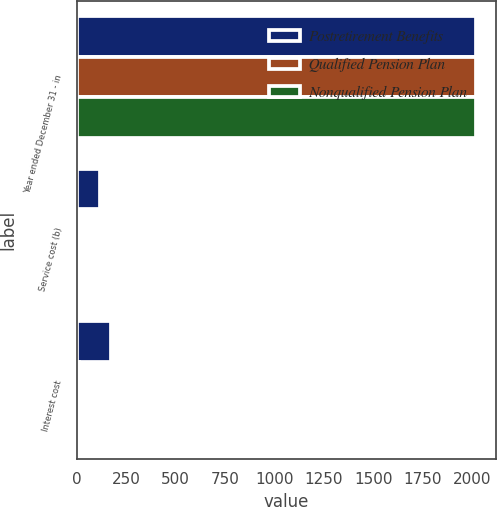Convert chart. <chart><loc_0><loc_0><loc_500><loc_500><stacked_bar_chart><ecel><fcel>Year ended December 31 - in<fcel>Service cost (b)<fcel>Interest cost<nl><fcel>Postretirement Benefits<fcel>2018<fcel>116<fcel>171<nl><fcel>Qualified Pension Plan<fcel>2018<fcel>3<fcel>9<nl><fcel>Nonqualified Pension Plan<fcel>2018<fcel>5<fcel>12<nl></chart> 